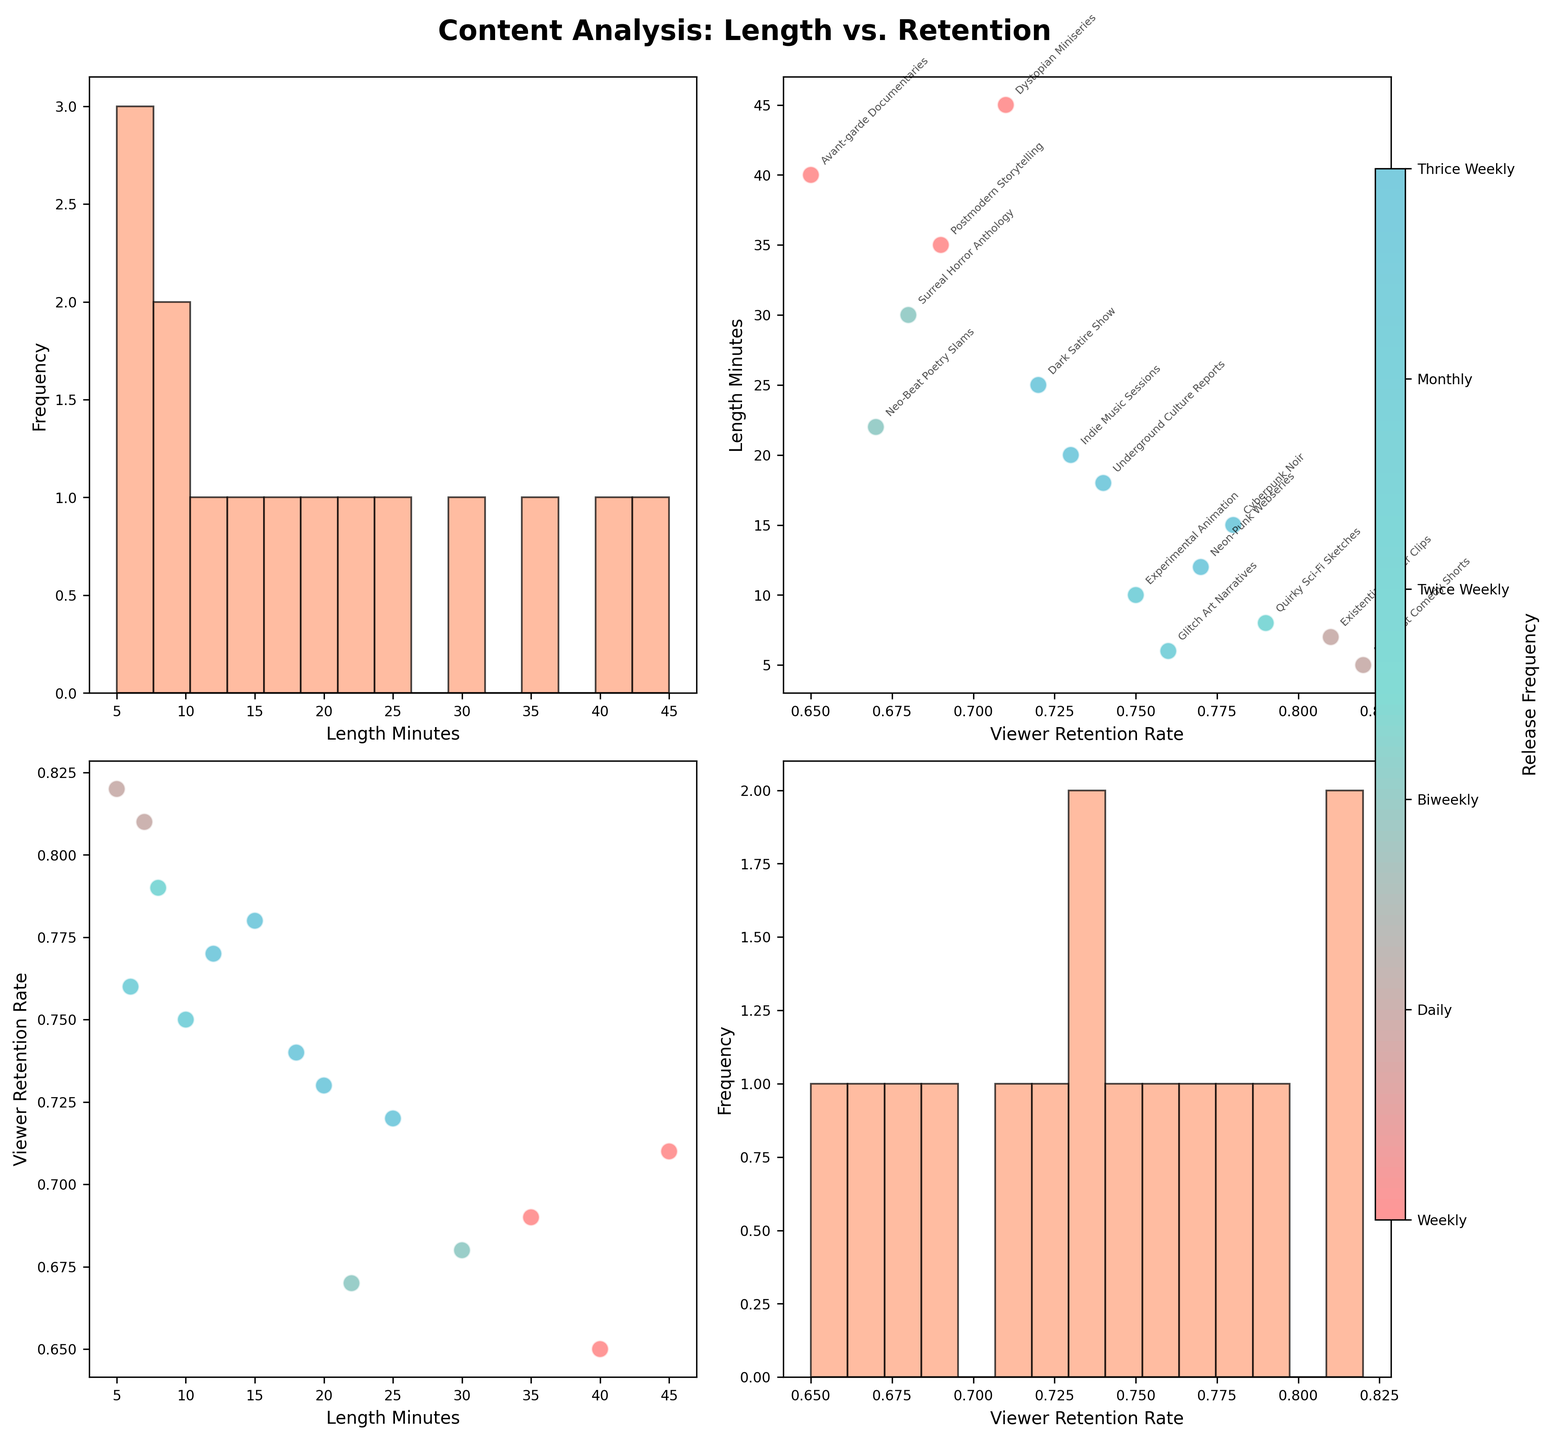Which content type has the highest viewer retention rate? Look at the scatterplot and identify the point with the highest retention rate value on the y-axis of the Viewer Retention Rate vs. Length Minutes plot. The label near this point will indicate the content type.
Answer: Absurdist Comedy Shorts Does content length seem to affect viewer retention rate? Analyze the scatterplot in the Viewer Retention Rate vs. Length Minutes plot. Observe if there's a general trend showing higher or lower retention rates with increasing content length.
Answer: No clear trend How many content types are released weekly? Identify the different release frequencies via the legend or color bar and count the points associated with the "Weekly" release frequency on the scatterplot matrices.
Answer: 5 Which release frequency has the lowest average viewer retention rate? Calculate the average viewer retention rate for each release frequency by visually estimating from the scatterplot and comparing. One can see that "Monthly" contents tend to have lower retention rates.
Answer: Monthly Do daily releases generally have higher retention rates than monthly releases? Compare the points related to daily releases and monthly releases on the scatterplot for Viewer Retention Rate vs. Length Minutes. Daily releases tend to be higher in viewer retention.
Answer: Yes Is there a noticeable pattern between release frequency and content length? Review the color distribution along the length minutes axis in the scatterplot matrix. No specific pattern is seen, indicating no obvious correlation.
Answer: No What content length sees the highest retention rate for biweekly releases? Look for the biweekly release content points on the Viewer Retention Rate vs. Length Minutes plot, and identify the highest y-value.
Answer: 45 minutes Which content type has a viewer retention rate close to 0.8 and is released twice weekly? Locate the point near 0.8 on the Viewer Retention Rate axis and observe its label while ensuring it corresponds to a Twice Weekly release.
Answer: Glitch Art Narratives How does the retention rate of Neon-Punk Webseries compare to Underground Culture Reports? Identify the points for both content types and compare their y-values for Viewer Retention Rate on the scatterplot.
Answer: Slightly lower Which data point represents the longest content length and what is its release frequency? Find the point with the highest value on the Length Minutes axis. Check the color or label to identify the release frequency.
Answer: Dystopian Miniseries, Biweekly 